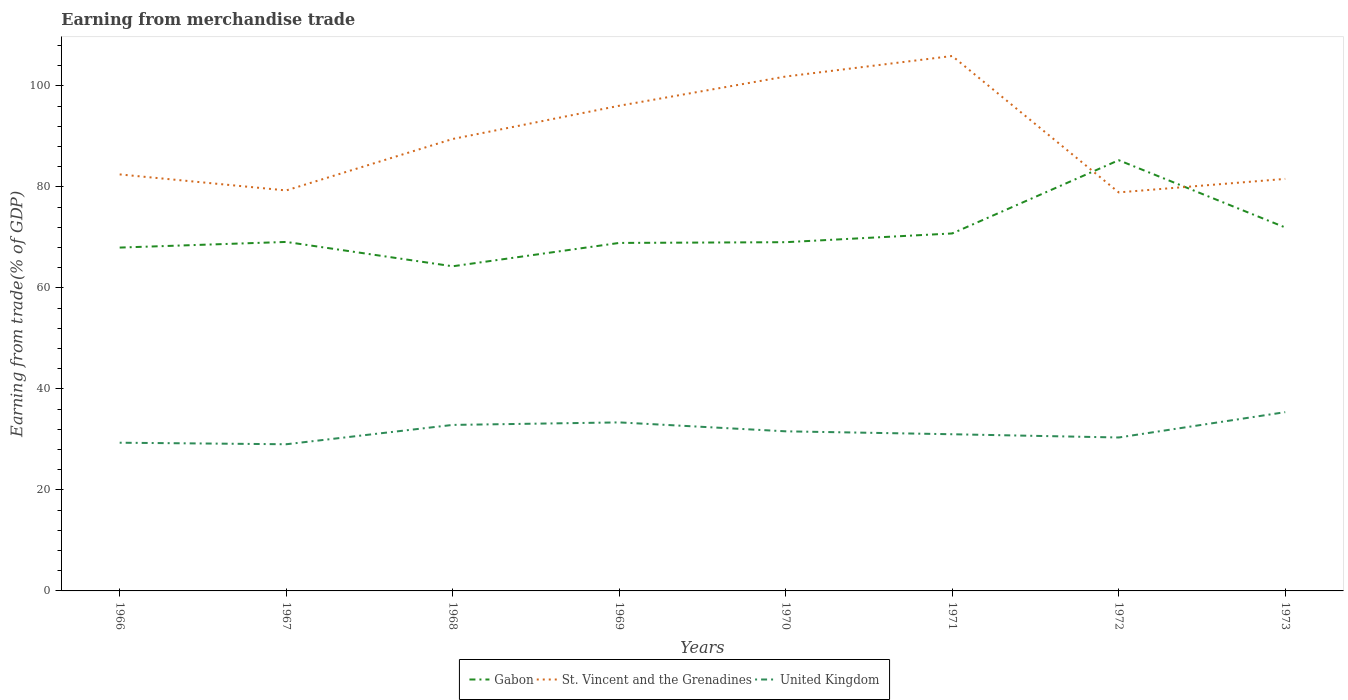How many different coloured lines are there?
Offer a terse response. 3. Is the number of lines equal to the number of legend labels?
Ensure brevity in your answer.  Yes. Across all years, what is the maximum earnings from trade in St. Vincent and the Grenadines?
Offer a terse response. 78.93. In which year was the earnings from trade in United Kingdom maximum?
Give a very brief answer. 1967. What is the total earnings from trade in United Kingdom in the graph?
Your answer should be compact. -4.33. What is the difference between the highest and the second highest earnings from trade in St. Vincent and the Grenadines?
Offer a terse response. 27.01. How many lines are there?
Provide a short and direct response. 3. Are the values on the major ticks of Y-axis written in scientific E-notation?
Your answer should be compact. No. Does the graph contain any zero values?
Ensure brevity in your answer.  No. Does the graph contain grids?
Provide a short and direct response. No. Where does the legend appear in the graph?
Provide a short and direct response. Bottom center. How are the legend labels stacked?
Provide a short and direct response. Horizontal. What is the title of the graph?
Provide a succinct answer. Earning from merchandise trade. Does "Pacific island small states" appear as one of the legend labels in the graph?
Ensure brevity in your answer.  No. What is the label or title of the Y-axis?
Give a very brief answer. Earning from trade(% of GDP). What is the Earning from trade(% of GDP) in Gabon in 1966?
Ensure brevity in your answer.  68. What is the Earning from trade(% of GDP) in St. Vincent and the Grenadines in 1966?
Your answer should be very brief. 82.49. What is the Earning from trade(% of GDP) of United Kingdom in 1966?
Offer a terse response. 29.35. What is the Earning from trade(% of GDP) of Gabon in 1967?
Provide a short and direct response. 69.11. What is the Earning from trade(% of GDP) in St. Vincent and the Grenadines in 1967?
Keep it short and to the point. 79.31. What is the Earning from trade(% of GDP) of United Kingdom in 1967?
Keep it short and to the point. 29.04. What is the Earning from trade(% of GDP) of Gabon in 1968?
Your response must be concise. 64.29. What is the Earning from trade(% of GDP) of St. Vincent and the Grenadines in 1968?
Keep it short and to the point. 89.5. What is the Earning from trade(% of GDP) of United Kingdom in 1968?
Give a very brief answer. 32.87. What is the Earning from trade(% of GDP) of Gabon in 1969?
Offer a terse response. 68.92. What is the Earning from trade(% of GDP) of St. Vincent and the Grenadines in 1969?
Provide a short and direct response. 96.08. What is the Earning from trade(% of GDP) in United Kingdom in 1969?
Give a very brief answer. 33.37. What is the Earning from trade(% of GDP) of Gabon in 1970?
Make the answer very short. 69.06. What is the Earning from trade(% of GDP) in St. Vincent and the Grenadines in 1970?
Offer a terse response. 101.87. What is the Earning from trade(% of GDP) of United Kingdom in 1970?
Offer a terse response. 31.61. What is the Earning from trade(% of GDP) of Gabon in 1971?
Provide a short and direct response. 70.79. What is the Earning from trade(% of GDP) of St. Vincent and the Grenadines in 1971?
Give a very brief answer. 105.94. What is the Earning from trade(% of GDP) of United Kingdom in 1971?
Provide a short and direct response. 31.03. What is the Earning from trade(% of GDP) of Gabon in 1972?
Offer a very short reply. 85.3. What is the Earning from trade(% of GDP) in St. Vincent and the Grenadines in 1972?
Offer a terse response. 78.93. What is the Earning from trade(% of GDP) of United Kingdom in 1972?
Give a very brief answer. 30.39. What is the Earning from trade(% of GDP) of Gabon in 1973?
Keep it short and to the point. 71.98. What is the Earning from trade(% of GDP) of St. Vincent and the Grenadines in 1973?
Your answer should be very brief. 81.6. What is the Earning from trade(% of GDP) in United Kingdom in 1973?
Make the answer very short. 35.4. Across all years, what is the maximum Earning from trade(% of GDP) of Gabon?
Make the answer very short. 85.3. Across all years, what is the maximum Earning from trade(% of GDP) in St. Vincent and the Grenadines?
Your answer should be very brief. 105.94. Across all years, what is the maximum Earning from trade(% of GDP) of United Kingdom?
Your response must be concise. 35.4. Across all years, what is the minimum Earning from trade(% of GDP) of Gabon?
Make the answer very short. 64.29. Across all years, what is the minimum Earning from trade(% of GDP) of St. Vincent and the Grenadines?
Provide a succinct answer. 78.93. Across all years, what is the minimum Earning from trade(% of GDP) in United Kingdom?
Keep it short and to the point. 29.04. What is the total Earning from trade(% of GDP) in Gabon in the graph?
Offer a terse response. 567.46. What is the total Earning from trade(% of GDP) in St. Vincent and the Grenadines in the graph?
Offer a very short reply. 715.72. What is the total Earning from trade(% of GDP) in United Kingdom in the graph?
Provide a short and direct response. 253.07. What is the difference between the Earning from trade(% of GDP) of Gabon in 1966 and that in 1967?
Your response must be concise. -1.12. What is the difference between the Earning from trade(% of GDP) of St. Vincent and the Grenadines in 1966 and that in 1967?
Give a very brief answer. 3.17. What is the difference between the Earning from trade(% of GDP) in United Kingdom in 1966 and that in 1967?
Ensure brevity in your answer.  0.31. What is the difference between the Earning from trade(% of GDP) of Gabon in 1966 and that in 1968?
Give a very brief answer. 3.7. What is the difference between the Earning from trade(% of GDP) of St. Vincent and the Grenadines in 1966 and that in 1968?
Your response must be concise. -7.02. What is the difference between the Earning from trade(% of GDP) in United Kingdom in 1966 and that in 1968?
Provide a short and direct response. -3.52. What is the difference between the Earning from trade(% of GDP) in Gabon in 1966 and that in 1969?
Make the answer very short. -0.92. What is the difference between the Earning from trade(% of GDP) of St. Vincent and the Grenadines in 1966 and that in 1969?
Offer a terse response. -13.6. What is the difference between the Earning from trade(% of GDP) of United Kingdom in 1966 and that in 1969?
Your answer should be compact. -4.02. What is the difference between the Earning from trade(% of GDP) in Gabon in 1966 and that in 1970?
Your response must be concise. -1.07. What is the difference between the Earning from trade(% of GDP) in St. Vincent and the Grenadines in 1966 and that in 1970?
Make the answer very short. -19.39. What is the difference between the Earning from trade(% of GDP) of United Kingdom in 1966 and that in 1970?
Your answer should be very brief. -2.26. What is the difference between the Earning from trade(% of GDP) in Gabon in 1966 and that in 1971?
Offer a very short reply. -2.8. What is the difference between the Earning from trade(% of GDP) of St. Vincent and the Grenadines in 1966 and that in 1971?
Make the answer very short. -23.45. What is the difference between the Earning from trade(% of GDP) in United Kingdom in 1966 and that in 1971?
Make the answer very short. -1.68. What is the difference between the Earning from trade(% of GDP) in Gabon in 1966 and that in 1972?
Provide a succinct answer. -17.31. What is the difference between the Earning from trade(% of GDP) of St. Vincent and the Grenadines in 1966 and that in 1972?
Offer a very short reply. 3.56. What is the difference between the Earning from trade(% of GDP) in United Kingdom in 1966 and that in 1972?
Your answer should be compact. -1.03. What is the difference between the Earning from trade(% of GDP) in Gabon in 1966 and that in 1973?
Offer a terse response. -3.98. What is the difference between the Earning from trade(% of GDP) of St. Vincent and the Grenadines in 1966 and that in 1973?
Your answer should be very brief. 0.89. What is the difference between the Earning from trade(% of GDP) in United Kingdom in 1966 and that in 1973?
Give a very brief answer. -6.05. What is the difference between the Earning from trade(% of GDP) in Gabon in 1967 and that in 1968?
Give a very brief answer. 4.82. What is the difference between the Earning from trade(% of GDP) of St. Vincent and the Grenadines in 1967 and that in 1968?
Offer a very short reply. -10.19. What is the difference between the Earning from trade(% of GDP) in United Kingdom in 1967 and that in 1968?
Your response must be concise. -3.83. What is the difference between the Earning from trade(% of GDP) of Gabon in 1967 and that in 1969?
Provide a succinct answer. 0.2. What is the difference between the Earning from trade(% of GDP) in St. Vincent and the Grenadines in 1967 and that in 1969?
Offer a terse response. -16.77. What is the difference between the Earning from trade(% of GDP) in United Kingdom in 1967 and that in 1969?
Make the answer very short. -4.33. What is the difference between the Earning from trade(% of GDP) of Gabon in 1967 and that in 1970?
Offer a very short reply. 0.05. What is the difference between the Earning from trade(% of GDP) of St. Vincent and the Grenadines in 1967 and that in 1970?
Give a very brief answer. -22.56. What is the difference between the Earning from trade(% of GDP) of United Kingdom in 1967 and that in 1970?
Provide a short and direct response. -2.56. What is the difference between the Earning from trade(% of GDP) of Gabon in 1967 and that in 1971?
Your answer should be compact. -1.68. What is the difference between the Earning from trade(% of GDP) of St. Vincent and the Grenadines in 1967 and that in 1971?
Keep it short and to the point. -26.63. What is the difference between the Earning from trade(% of GDP) of United Kingdom in 1967 and that in 1971?
Keep it short and to the point. -1.98. What is the difference between the Earning from trade(% of GDP) in Gabon in 1967 and that in 1972?
Your answer should be compact. -16.19. What is the difference between the Earning from trade(% of GDP) of St. Vincent and the Grenadines in 1967 and that in 1972?
Your answer should be compact. 0.39. What is the difference between the Earning from trade(% of GDP) in United Kingdom in 1967 and that in 1972?
Offer a terse response. -1.34. What is the difference between the Earning from trade(% of GDP) in Gabon in 1967 and that in 1973?
Your answer should be compact. -2.86. What is the difference between the Earning from trade(% of GDP) in St. Vincent and the Grenadines in 1967 and that in 1973?
Your answer should be very brief. -2.29. What is the difference between the Earning from trade(% of GDP) in United Kingdom in 1967 and that in 1973?
Your response must be concise. -6.36. What is the difference between the Earning from trade(% of GDP) in Gabon in 1968 and that in 1969?
Keep it short and to the point. -4.62. What is the difference between the Earning from trade(% of GDP) of St. Vincent and the Grenadines in 1968 and that in 1969?
Ensure brevity in your answer.  -6.58. What is the difference between the Earning from trade(% of GDP) of United Kingdom in 1968 and that in 1969?
Offer a terse response. -0.5. What is the difference between the Earning from trade(% of GDP) in Gabon in 1968 and that in 1970?
Ensure brevity in your answer.  -4.77. What is the difference between the Earning from trade(% of GDP) of St. Vincent and the Grenadines in 1968 and that in 1970?
Your answer should be compact. -12.37. What is the difference between the Earning from trade(% of GDP) of United Kingdom in 1968 and that in 1970?
Your response must be concise. 1.27. What is the difference between the Earning from trade(% of GDP) of Gabon in 1968 and that in 1971?
Your answer should be very brief. -6.5. What is the difference between the Earning from trade(% of GDP) of St. Vincent and the Grenadines in 1968 and that in 1971?
Make the answer very short. -16.43. What is the difference between the Earning from trade(% of GDP) in United Kingdom in 1968 and that in 1971?
Make the answer very short. 1.85. What is the difference between the Earning from trade(% of GDP) in Gabon in 1968 and that in 1972?
Offer a terse response. -21.01. What is the difference between the Earning from trade(% of GDP) in St. Vincent and the Grenadines in 1968 and that in 1972?
Make the answer very short. 10.58. What is the difference between the Earning from trade(% of GDP) in United Kingdom in 1968 and that in 1972?
Provide a short and direct response. 2.49. What is the difference between the Earning from trade(% of GDP) in Gabon in 1968 and that in 1973?
Provide a short and direct response. -7.68. What is the difference between the Earning from trade(% of GDP) of St. Vincent and the Grenadines in 1968 and that in 1973?
Make the answer very short. 7.91. What is the difference between the Earning from trade(% of GDP) of United Kingdom in 1968 and that in 1973?
Your answer should be compact. -2.53. What is the difference between the Earning from trade(% of GDP) in Gabon in 1969 and that in 1970?
Ensure brevity in your answer.  -0.15. What is the difference between the Earning from trade(% of GDP) in St. Vincent and the Grenadines in 1969 and that in 1970?
Keep it short and to the point. -5.79. What is the difference between the Earning from trade(% of GDP) of United Kingdom in 1969 and that in 1970?
Ensure brevity in your answer.  1.77. What is the difference between the Earning from trade(% of GDP) of Gabon in 1969 and that in 1971?
Make the answer very short. -1.88. What is the difference between the Earning from trade(% of GDP) of St. Vincent and the Grenadines in 1969 and that in 1971?
Offer a terse response. -9.85. What is the difference between the Earning from trade(% of GDP) in United Kingdom in 1969 and that in 1971?
Your response must be concise. 2.35. What is the difference between the Earning from trade(% of GDP) in Gabon in 1969 and that in 1972?
Provide a short and direct response. -16.38. What is the difference between the Earning from trade(% of GDP) in St. Vincent and the Grenadines in 1969 and that in 1972?
Your response must be concise. 17.16. What is the difference between the Earning from trade(% of GDP) of United Kingdom in 1969 and that in 1972?
Provide a short and direct response. 2.99. What is the difference between the Earning from trade(% of GDP) of Gabon in 1969 and that in 1973?
Provide a succinct answer. -3.06. What is the difference between the Earning from trade(% of GDP) of St. Vincent and the Grenadines in 1969 and that in 1973?
Provide a short and direct response. 14.49. What is the difference between the Earning from trade(% of GDP) of United Kingdom in 1969 and that in 1973?
Provide a short and direct response. -2.03. What is the difference between the Earning from trade(% of GDP) in Gabon in 1970 and that in 1971?
Give a very brief answer. -1.73. What is the difference between the Earning from trade(% of GDP) of St. Vincent and the Grenadines in 1970 and that in 1971?
Offer a very short reply. -4.07. What is the difference between the Earning from trade(% of GDP) in United Kingdom in 1970 and that in 1971?
Offer a terse response. 0.58. What is the difference between the Earning from trade(% of GDP) of Gabon in 1970 and that in 1972?
Your answer should be compact. -16.24. What is the difference between the Earning from trade(% of GDP) in St. Vincent and the Grenadines in 1970 and that in 1972?
Offer a very short reply. 22.95. What is the difference between the Earning from trade(% of GDP) of United Kingdom in 1970 and that in 1972?
Provide a short and direct response. 1.22. What is the difference between the Earning from trade(% of GDP) of Gabon in 1970 and that in 1973?
Provide a short and direct response. -2.91. What is the difference between the Earning from trade(% of GDP) in St. Vincent and the Grenadines in 1970 and that in 1973?
Make the answer very short. 20.27. What is the difference between the Earning from trade(% of GDP) in United Kingdom in 1970 and that in 1973?
Provide a succinct answer. -3.8. What is the difference between the Earning from trade(% of GDP) in Gabon in 1971 and that in 1972?
Offer a very short reply. -14.51. What is the difference between the Earning from trade(% of GDP) of St. Vincent and the Grenadines in 1971 and that in 1972?
Give a very brief answer. 27.01. What is the difference between the Earning from trade(% of GDP) in United Kingdom in 1971 and that in 1972?
Ensure brevity in your answer.  0.64. What is the difference between the Earning from trade(% of GDP) of Gabon in 1971 and that in 1973?
Your answer should be compact. -1.18. What is the difference between the Earning from trade(% of GDP) of St. Vincent and the Grenadines in 1971 and that in 1973?
Offer a very short reply. 24.34. What is the difference between the Earning from trade(% of GDP) in United Kingdom in 1971 and that in 1973?
Give a very brief answer. -4.38. What is the difference between the Earning from trade(% of GDP) of Gabon in 1972 and that in 1973?
Offer a very short reply. 13.32. What is the difference between the Earning from trade(% of GDP) of St. Vincent and the Grenadines in 1972 and that in 1973?
Provide a succinct answer. -2.67. What is the difference between the Earning from trade(% of GDP) in United Kingdom in 1972 and that in 1973?
Keep it short and to the point. -5.02. What is the difference between the Earning from trade(% of GDP) in Gabon in 1966 and the Earning from trade(% of GDP) in St. Vincent and the Grenadines in 1967?
Offer a terse response. -11.32. What is the difference between the Earning from trade(% of GDP) in Gabon in 1966 and the Earning from trade(% of GDP) in United Kingdom in 1967?
Offer a very short reply. 38.95. What is the difference between the Earning from trade(% of GDP) of St. Vincent and the Grenadines in 1966 and the Earning from trade(% of GDP) of United Kingdom in 1967?
Make the answer very short. 53.44. What is the difference between the Earning from trade(% of GDP) of Gabon in 1966 and the Earning from trade(% of GDP) of St. Vincent and the Grenadines in 1968?
Offer a very short reply. -21.51. What is the difference between the Earning from trade(% of GDP) in Gabon in 1966 and the Earning from trade(% of GDP) in United Kingdom in 1968?
Provide a short and direct response. 35.12. What is the difference between the Earning from trade(% of GDP) in St. Vincent and the Grenadines in 1966 and the Earning from trade(% of GDP) in United Kingdom in 1968?
Offer a very short reply. 49.61. What is the difference between the Earning from trade(% of GDP) of Gabon in 1966 and the Earning from trade(% of GDP) of St. Vincent and the Grenadines in 1969?
Make the answer very short. -28.09. What is the difference between the Earning from trade(% of GDP) in Gabon in 1966 and the Earning from trade(% of GDP) in United Kingdom in 1969?
Offer a terse response. 34.62. What is the difference between the Earning from trade(% of GDP) in St. Vincent and the Grenadines in 1966 and the Earning from trade(% of GDP) in United Kingdom in 1969?
Give a very brief answer. 49.11. What is the difference between the Earning from trade(% of GDP) of Gabon in 1966 and the Earning from trade(% of GDP) of St. Vincent and the Grenadines in 1970?
Your answer should be very brief. -33.88. What is the difference between the Earning from trade(% of GDP) of Gabon in 1966 and the Earning from trade(% of GDP) of United Kingdom in 1970?
Ensure brevity in your answer.  36.39. What is the difference between the Earning from trade(% of GDP) in St. Vincent and the Grenadines in 1966 and the Earning from trade(% of GDP) in United Kingdom in 1970?
Your response must be concise. 50.88. What is the difference between the Earning from trade(% of GDP) in Gabon in 1966 and the Earning from trade(% of GDP) in St. Vincent and the Grenadines in 1971?
Your answer should be compact. -37.94. What is the difference between the Earning from trade(% of GDP) in Gabon in 1966 and the Earning from trade(% of GDP) in United Kingdom in 1971?
Provide a short and direct response. 36.97. What is the difference between the Earning from trade(% of GDP) in St. Vincent and the Grenadines in 1966 and the Earning from trade(% of GDP) in United Kingdom in 1971?
Your answer should be very brief. 51.46. What is the difference between the Earning from trade(% of GDP) in Gabon in 1966 and the Earning from trade(% of GDP) in St. Vincent and the Grenadines in 1972?
Ensure brevity in your answer.  -10.93. What is the difference between the Earning from trade(% of GDP) in Gabon in 1966 and the Earning from trade(% of GDP) in United Kingdom in 1972?
Make the answer very short. 37.61. What is the difference between the Earning from trade(% of GDP) of St. Vincent and the Grenadines in 1966 and the Earning from trade(% of GDP) of United Kingdom in 1972?
Keep it short and to the point. 52.1. What is the difference between the Earning from trade(% of GDP) in Gabon in 1966 and the Earning from trade(% of GDP) in St. Vincent and the Grenadines in 1973?
Provide a succinct answer. -13.6. What is the difference between the Earning from trade(% of GDP) of Gabon in 1966 and the Earning from trade(% of GDP) of United Kingdom in 1973?
Offer a very short reply. 32.59. What is the difference between the Earning from trade(% of GDP) in St. Vincent and the Grenadines in 1966 and the Earning from trade(% of GDP) in United Kingdom in 1973?
Keep it short and to the point. 47.08. What is the difference between the Earning from trade(% of GDP) of Gabon in 1967 and the Earning from trade(% of GDP) of St. Vincent and the Grenadines in 1968?
Your answer should be compact. -20.39. What is the difference between the Earning from trade(% of GDP) of Gabon in 1967 and the Earning from trade(% of GDP) of United Kingdom in 1968?
Provide a short and direct response. 36.24. What is the difference between the Earning from trade(% of GDP) of St. Vincent and the Grenadines in 1967 and the Earning from trade(% of GDP) of United Kingdom in 1968?
Keep it short and to the point. 46.44. What is the difference between the Earning from trade(% of GDP) in Gabon in 1967 and the Earning from trade(% of GDP) in St. Vincent and the Grenadines in 1969?
Make the answer very short. -26.97. What is the difference between the Earning from trade(% of GDP) of Gabon in 1967 and the Earning from trade(% of GDP) of United Kingdom in 1969?
Provide a short and direct response. 35.74. What is the difference between the Earning from trade(% of GDP) of St. Vincent and the Grenadines in 1967 and the Earning from trade(% of GDP) of United Kingdom in 1969?
Ensure brevity in your answer.  45.94. What is the difference between the Earning from trade(% of GDP) of Gabon in 1967 and the Earning from trade(% of GDP) of St. Vincent and the Grenadines in 1970?
Ensure brevity in your answer.  -32.76. What is the difference between the Earning from trade(% of GDP) in Gabon in 1967 and the Earning from trade(% of GDP) in United Kingdom in 1970?
Offer a terse response. 37.51. What is the difference between the Earning from trade(% of GDP) in St. Vincent and the Grenadines in 1967 and the Earning from trade(% of GDP) in United Kingdom in 1970?
Provide a short and direct response. 47.7. What is the difference between the Earning from trade(% of GDP) of Gabon in 1967 and the Earning from trade(% of GDP) of St. Vincent and the Grenadines in 1971?
Keep it short and to the point. -36.82. What is the difference between the Earning from trade(% of GDP) in Gabon in 1967 and the Earning from trade(% of GDP) in United Kingdom in 1971?
Offer a terse response. 38.09. What is the difference between the Earning from trade(% of GDP) of St. Vincent and the Grenadines in 1967 and the Earning from trade(% of GDP) of United Kingdom in 1971?
Make the answer very short. 48.28. What is the difference between the Earning from trade(% of GDP) of Gabon in 1967 and the Earning from trade(% of GDP) of St. Vincent and the Grenadines in 1972?
Ensure brevity in your answer.  -9.81. What is the difference between the Earning from trade(% of GDP) of Gabon in 1967 and the Earning from trade(% of GDP) of United Kingdom in 1972?
Ensure brevity in your answer.  38.73. What is the difference between the Earning from trade(% of GDP) of St. Vincent and the Grenadines in 1967 and the Earning from trade(% of GDP) of United Kingdom in 1972?
Keep it short and to the point. 48.93. What is the difference between the Earning from trade(% of GDP) in Gabon in 1967 and the Earning from trade(% of GDP) in St. Vincent and the Grenadines in 1973?
Make the answer very short. -12.48. What is the difference between the Earning from trade(% of GDP) in Gabon in 1967 and the Earning from trade(% of GDP) in United Kingdom in 1973?
Your response must be concise. 33.71. What is the difference between the Earning from trade(% of GDP) of St. Vincent and the Grenadines in 1967 and the Earning from trade(% of GDP) of United Kingdom in 1973?
Your answer should be compact. 43.91. What is the difference between the Earning from trade(% of GDP) of Gabon in 1968 and the Earning from trade(% of GDP) of St. Vincent and the Grenadines in 1969?
Provide a succinct answer. -31.79. What is the difference between the Earning from trade(% of GDP) in Gabon in 1968 and the Earning from trade(% of GDP) in United Kingdom in 1969?
Give a very brief answer. 30.92. What is the difference between the Earning from trade(% of GDP) in St. Vincent and the Grenadines in 1968 and the Earning from trade(% of GDP) in United Kingdom in 1969?
Your answer should be very brief. 56.13. What is the difference between the Earning from trade(% of GDP) of Gabon in 1968 and the Earning from trade(% of GDP) of St. Vincent and the Grenadines in 1970?
Provide a succinct answer. -37.58. What is the difference between the Earning from trade(% of GDP) in Gabon in 1968 and the Earning from trade(% of GDP) in United Kingdom in 1970?
Make the answer very short. 32.69. What is the difference between the Earning from trade(% of GDP) of St. Vincent and the Grenadines in 1968 and the Earning from trade(% of GDP) of United Kingdom in 1970?
Your answer should be very brief. 57.9. What is the difference between the Earning from trade(% of GDP) in Gabon in 1968 and the Earning from trade(% of GDP) in St. Vincent and the Grenadines in 1971?
Offer a terse response. -41.65. What is the difference between the Earning from trade(% of GDP) of Gabon in 1968 and the Earning from trade(% of GDP) of United Kingdom in 1971?
Ensure brevity in your answer.  33.27. What is the difference between the Earning from trade(% of GDP) of St. Vincent and the Grenadines in 1968 and the Earning from trade(% of GDP) of United Kingdom in 1971?
Your answer should be very brief. 58.48. What is the difference between the Earning from trade(% of GDP) in Gabon in 1968 and the Earning from trade(% of GDP) in St. Vincent and the Grenadines in 1972?
Offer a terse response. -14.63. What is the difference between the Earning from trade(% of GDP) in Gabon in 1968 and the Earning from trade(% of GDP) in United Kingdom in 1972?
Your response must be concise. 33.91. What is the difference between the Earning from trade(% of GDP) in St. Vincent and the Grenadines in 1968 and the Earning from trade(% of GDP) in United Kingdom in 1972?
Offer a terse response. 59.12. What is the difference between the Earning from trade(% of GDP) of Gabon in 1968 and the Earning from trade(% of GDP) of St. Vincent and the Grenadines in 1973?
Your answer should be very brief. -17.3. What is the difference between the Earning from trade(% of GDP) in Gabon in 1968 and the Earning from trade(% of GDP) in United Kingdom in 1973?
Your answer should be compact. 28.89. What is the difference between the Earning from trade(% of GDP) in St. Vincent and the Grenadines in 1968 and the Earning from trade(% of GDP) in United Kingdom in 1973?
Keep it short and to the point. 54.1. What is the difference between the Earning from trade(% of GDP) of Gabon in 1969 and the Earning from trade(% of GDP) of St. Vincent and the Grenadines in 1970?
Your answer should be compact. -32.96. What is the difference between the Earning from trade(% of GDP) in Gabon in 1969 and the Earning from trade(% of GDP) in United Kingdom in 1970?
Ensure brevity in your answer.  37.31. What is the difference between the Earning from trade(% of GDP) in St. Vincent and the Grenadines in 1969 and the Earning from trade(% of GDP) in United Kingdom in 1970?
Keep it short and to the point. 64.48. What is the difference between the Earning from trade(% of GDP) in Gabon in 1969 and the Earning from trade(% of GDP) in St. Vincent and the Grenadines in 1971?
Your response must be concise. -37.02. What is the difference between the Earning from trade(% of GDP) of Gabon in 1969 and the Earning from trade(% of GDP) of United Kingdom in 1971?
Keep it short and to the point. 37.89. What is the difference between the Earning from trade(% of GDP) of St. Vincent and the Grenadines in 1969 and the Earning from trade(% of GDP) of United Kingdom in 1971?
Make the answer very short. 65.06. What is the difference between the Earning from trade(% of GDP) in Gabon in 1969 and the Earning from trade(% of GDP) in St. Vincent and the Grenadines in 1972?
Your answer should be compact. -10.01. What is the difference between the Earning from trade(% of GDP) of Gabon in 1969 and the Earning from trade(% of GDP) of United Kingdom in 1972?
Your answer should be very brief. 38.53. What is the difference between the Earning from trade(% of GDP) of St. Vincent and the Grenadines in 1969 and the Earning from trade(% of GDP) of United Kingdom in 1972?
Offer a terse response. 65.7. What is the difference between the Earning from trade(% of GDP) of Gabon in 1969 and the Earning from trade(% of GDP) of St. Vincent and the Grenadines in 1973?
Provide a short and direct response. -12.68. What is the difference between the Earning from trade(% of GDP) in Gabon in 1969 and the Earning from trade(% of GDP) in United Kingdom in 1973?
Provide a short and direct response. 33.51. What is the difference between the Earning from trade(% of GDP) of St. Vincent and the Grenadines in 1969 and the Earning from trade(% of GDP) of United Kingdom in 1973?
Offer a very short reply. 60.68. What is the difference between the Earning from trade(% of GDP) of Gabon in 1970 and the Earning from trade(% of GDP) of St. Vincent and the Grenadines in 1971?
Your answer should be very brief. -36.87. What is the difference between the Earning from trade(% of GDP) in Gabon in 1970 and the Earning from trade(% of GDP) in United Kingdom in 1971?
Keep it short and to the point. 38.04. What is the difference between the Earning from trade(% of GDP) of St. Vincent and the Grenadines in 1970 and the Earning from trade(% of GDP) of United Kingdom in 1971?
Your response must be concise. 70.84. What is the difference between the Earning from trade(% of GDP) of Gabon in 1970 and the Earning from trade(% of GDP) of St. Vincent and the Grenadines in 1972?
Ensure brevity in your answer.  -9.86. What is the difference between the Earning from trade(% of GDP) of Gabon in 1970 and the Earning from trade(% of GDP) of United Kingdom in 1972?
Provide a short and direct response. 38.68. What is the difference between the Earning from trade(% of GDP) in St. Vincent and the Grenadines in 1970 and the Earning from trade(% of GDP) in United Kingdom in 1972?
Keep it short and to the point. 71.49. What is the difference between the Earning from trade(% of GDP) in Gabon in 1970 and the Earning from trade(% of GDP) in St. Vincent and the Grenadines in 1973?
Give a very brief answer. -12.53. What is the difference between the Earning from trade(% of GDP) in Gabon in 1970 and the Earning from trade(% of GDP) in United Kingdom in 1973?
Ensure brevity in your answer.  33.66. What is the difference between the Earning from trade(% of GDP) of St. Vincent and the Grenadines in 1970 and the Earning from trade(% of GDP) of United Kingdom in 1973?
Your answer should be very brief. 66.47. What is the difference between the Earning from trade(% of GDP) of Gabon in 1971 and the Earning from trade(% of GDP) of St. Vincent and the Grenadines in 1972?
Provide a short and direct response. -8.13. What is the difference between the Earning from trade(% of GDP) of Gabon in 1971 and the Earning from trade(% of GDP) of United Kingdom in 1972?
Give a very brief answer. 40.41. What is the difference between the Earning from trade(% of GDP) in St. Vincent and the Grenadines in 1971 and the Earning from trade(% of GDP) in United Kingdom in 1972?
Offer a terse response. 75.55. What is the difference between the Earning from trade(% of GDP) of Gabon in 1971 and the Earning from trade(% of GDP) of St. Vincent and the Grenadines in 1973?
Your answer should be very brief. -10.8. What is the difference between the Earning from trade(% of GDP) of Gabon in 1971 and the Earning from trade(% of GDP) of United Kingdom in 1973?
Offer a terse response. 35.39. What is the difference between the Earning from trade(% of GDP) in St. Vincent and the Grenadines in 1971 and the Earning from trade(% of GDP) in United Kingdom in 1973?
Your answer should be very brief. 70.53. What is the difference between the Earning from trade(% of GDP) of Gabon in 1972 and the Earning from trade(% of GDP) of St. Vincent and the Grenadines in 1973?
Your response must be concise. 3.7. What is the difference between the Earning from trade(% of GDP) in Gabon in 1972 and the Earning from trade(% of GDP) in United Kingdom in 1973?
Your answer should be compact. 49.9. What is the difference between the Earning from trade(% of GDP) in St. Vincent and the Grenadines in 1972 and the Earning from trade(% of GDP) in United Kingdom in 1973?
Offer a terse response. 43.52. What is the average Earning from trade(% of GDP) in Gabon per year?
Provide a short and direct response. 70.93. What is the average Earning from trade(% of GDP) in St. Vincent and the Grenadines per year?
Your response must be concise. 89.47. What is the average Earning from trade(% of GDP) in United Kingdom per year?
Make the answer very short. 31.63. In the year 1966, what is the difference between the Earning from trade(% of GDP) of Gabon and Earning from trade(% of GDP) of St. Vincent and the Grenadines?
Your answer should be compact. -14.49. In the year 1966, what is the difference between the Earning from trade(% of GDP) of Gabon and Earning from trade(% of GDP) of United Kingdom?
Offer a terse response. 38.64. In the year 1966, what is the difference between the Earning from trade(% of GDP) of St. Vincent and the Grenadines and Earning from trade(% of GDP) of United Kingdom?
Give a very brief answer. 53.13. In the year 1967, what is the difference between the Earning from trade(% of GDP) of Gabon and Earning from trade(% of GDP) of St. Vincent and the Grenadines?
Offer a very short reply. -10.2. In the year 1967, what is the difference between the Earning from trade(% of GDP) of Gabon and Earning from trade(% of GDP) of United Kingdom?
Your answer should be very brief. 40.07. In the year 1967, what is the difference between the Earning from trade(% of GDP) of St. Vincent and the Grenadines and Earning from trade(% of GDP) of United Kingdom?
Your answer should be very brief. 50.27. In the year 1968, what is the difference between the Earning from trade(% of GDP) of Gabon and Earning from trade(% of GDP) of St. Vincent and the Grenadines?
Your answer should be compact. -25.21. In the year 1968, what is the difference between the Earning from trade(% of GDP) of Gabon and Earning from trade(% of GDP) of United Kingdom?
Provide a succinct answer. 31.42. In the year 1968, what is the difference between the Earning from trade(% of GDP) in St. Vincent and the Grenadines and Earning from trade(% of GDP) in United Kingdom?
Offer a very short reply. 56.63. In the year 1969, what is the difference between the Earning from trade(% of GDP) in Gabon and Earning from trade(% of GDP) in St. Vincent and the Grenadines?
Your answer should be very brief. -27.17. In the year 1969, what is the difference between the Earning from trade(% of GDP) in Gabon and Earning from trade(% of GDP) in United Kingdom?
Offer a terse response. 35.54. In the year 1969, what is the difference between the Earning from trade(% of GDP) in St. Vincent and the Grenadines and Earning from trade(% of GDP) in United Kingdom?
Your answer should be compact. 62.71. In the year 1970, what is the difference between the Earning from trade(% of GDP) in Gabon and Earning from trade(% of GDP) in St. Vincent and the Grenadines?
Provide a succinct answer. -32.81. In the year 1970, what is the difference between the Earning from trade(% of GDP) of Gabon and Earning from trade(% of GDP) of United Kingdom?
Ensure brevity in your answer.  37.46. In the year 1970, what is the difference between the Earning from trade(% of GDP) in St. Vincent and the Grenadines and Earning from trade(% of GDP) in United Kingdom?
Your response must be concise. 70.27. In the year 1971, what is the difference between the Earning from trade(% of GDP) of Gabon and Earning from trade(% of GDP) of St. Vincent and the Grenadines?
Offer a terse response. -35.14. In the year 1971, what is the difference between the Earning from trade(% of GDP) in Gabon and Earning from trade(% of GDP) in United Kingdom?
Ensure brevity in your answer.  39.77. In the year 1971, what is the difference between the Earning from trade(% of GDP) of St. Vincent and the Grenadines and Earning from trade(% of GDP) of United Kingdom?
Your answer should be compact. 74.91. In the year 1972, what is the difference between the Earning from trade(% of GDP) in Gabon and Earning from trade(% of GDP) in St. Vincent and the Grenadines?
Your response must be concise. 6.38. In the year 1972, what is the difference between the Earning from trade(% of GDP) in Gabon and Earning from trade(% of GDP) in United Kingdom?
Give a very brief answer. 54.92. In the year 1972, what is the difference between the Earning from trade(% of GDP) in St. Vincent and the Grenadines and Earning from trade(% of GDP) in United Kingdom?
Provide a succinct answer. 48.54. In the year 1973, what is the difference between the Earning from trade(% of GDP) of Gabon and Earning from trade(% of GDP) of St. Vincent and the Grenadines?
Provide a short and direct response. -9.62. In the year 1973, what is the difference between the Earning from trade(% of GDP) in Gabon and Earning from trade(% of GDP) in United Kingdom?
Provide a succinct answer. 36.57. In the year 1973, what is the difference between the Earning from trade(% of GDP) of St. Vincent and the Grenadines and Earning from trade(% of GDP) of United Kingdom?
Your answer should be compact. 46.19. What is the ratio of the Earning from trade(% of GDP) of Gabon in 1966 to that in 1967?
Offer a terse response. 0.98. What is the ratio of the Earning from trade(% of GDP) in United Kingdom in 1966 to that in 1967?
Give a very brief answer. 1.01. What is the ratio of the Earning from trade(% of GDP) in Gabon in 1966 to that in 1968?
Provide a short and direct response. 1.06. What is the ratio of the Earning from trade(% of GDP) in St. Vincent and the Grenadines in 1966 to that in 1968?
Make the answer very short. 0.92. What is the ratio of the Earning from trade(% of GDP) in United Kingdom in 1966 to that in 1968?
Offer a very short reply. 0.89. What is the ratio of the Earning from trade(% of GDP) in Gabon in 1966 to that in 1969?
Provide a succinct answer. 0.99. What is the ratio of the Earning from trade(% of GDP) of St. Vincent and the Grenadines in 1966 to that in 1969?
Provide a succinct answer. 0.86. What is the ratio of the Earning from trade(% of GDP) of United Kingdom in 1966 to that in 1969?
Offer a terse response. 0.88. What is the ratio of the Earning from trade(% of GDP) of Gabon in 1966 to that in 1970?
Offer a very short reply. 0.98. What is the ratio of the Earning from trade(% of GDP) in St. Vincent and the Grenadines in 1966 to that in 1970?
Provide a short and direct response. 0.81. What is the ratio of the Earning from trade(% of GDP) in United Kingdom in 1966 to that in 1970?
Provide a succinct answer. 0.93. What is the ratio of the Earning from trade(% of GDP) of Gabon in 1966 to that in 1971?
Provide a succinct answer. 0.96. What is the ratio of the Earning from trade(% of GDP) in St. Vincent and the Grenadines in 1966 to that in 1971?
Offer a terse response. 0.78. What is the ratio of the Earning from trade(% of GDP) in United Kingdom in 1966 to that in 1971?
Provide a short and direct response. 0.95. What is the ratio of the Earning from trade(% of GDP) of Gabon in 1966 to that in 1972?
Your answer should be very brief. 0.8. What is the ratio of the Earning from trade(% of GDP) of St. Vincent and the Grenadines in 1966 to that in 1972?
Provide a succinct answer. 1.05. What is the ratio of the Earning from trade(% of GDP) of United Kingdom in 1966 to that in 1972?
Give a very brief answer. 0.97. What is the ratio of the Earning from trade(% of GDP) in Gabon in 1966 to that in 1973?
Make the answer very short. 0.94. What is the ratio of the Earning from trade(% of GDP) in St. Vincent and the Grenadines in 1966 to that in 1973?
Make the answer very short. 1.01. What is the ratio of the Earning from trade(% of GDP) of United Kingdom in 1966 to that in 1973?
Provide a succinct answer. 0.83. What is the ratio of the Earning from trade(% of GDP) in Gabon in 1967 to that in 1968?
Offer a very short reply. 1.07. What is the ratio of the Earning from trade(% of GDP) in St. Vincent and the Grenadines in 1967 to that in 1968?
Offer a terse response. 0.89. What is the ratio of the Earning from trade(% of GDP) in United Kingdom in 1967 to that in 1968?
Your answer should be very brief. 0.88. What is the ratio of the Earning from trade(% of GDP) of St. Vincent and the Grenadines in 1967 to that in 1969?
Your response must be concise. 0.83. What is the ratio of the Earning from trade(% of GDP) in United Kingdom in 1967 to that in 1969?
Provide a short and direct response. 0.87. What is the ratio of the Earning from trade(% of GDP) in St. Vincent and the Grenadines in 1967 to that in 1970?
Offer a very short reply. 0.78. What is the ratio of the Earning from trade(% of GDP) in United Kingdom in 1967 to that in 1970?
Ensure brevity in your answer.  0.92. What is the ratio of the Earning from trade(% of GDP) of Gabon in 1967 to that in 1971?
Your answer should be compact. 0.98. What is the ratio of the Earning from trade(% of GDP) in St. Vincent and the Grenadines in 1967 to that in 1971?
Offer a very short reply. 0.75. What is the ratio of the Earning from trade(% of GDP) of United Kingdom in 1967 to that in 1971?
Offer a terse response. 0.94. What is the ratio of the Earning from trade(% of GDP) in Gabon in 1967 to that in 1972?
Your answer should be very brief. 0.81. What is the ratio of the Earning from trade(% of GDP) in United Kingdom in 1967 to that in 1972?
Your answer should be very brief. 0.96. What is the ratio of the Earning from trade(% of GDP) in Gabon in 1967 to that in 1973?
Your response must be concise. 0.96. What is the ratio of the Earning from trade(% of GDP) in St. Vincent and the Grenadines in 1967 to that in 1973?
Keep it short and to the point. 0.97. What is the ratio of the Earning from trade(% of GDP) in United Kingdom in 1967 to that in 1973?
Make the answer very short. 0.82. What is the ratio of the Earning from trade(% of GDP) in Gabon in 1968 to that in 1969?
Offer a terse response. 0.93. What is the ratio of the Earning from trade(% of GDP) of St. Vincent and the Grenadines in 1968 to that in 1969?
Keep it short and to the point. 0.93. What is the ratio of the Earning from trade(% of GDP) in United Kingdom in 1968 to that in 1969?
Offer a terse response. 0.98. What is the ratio of the Earning from trade(% of GDP) of Gabon in 1968 to that in 1970?
Your answer should be very brief. 0.93. What is the ratio of the Earning from trade(% of GDP) of St. Vincent and the Grenadines in 1968 to that in 1970?
Your answer should be compact. 0.88. What is the ratio of the Earning from trade(% of GDP) in United Kingdom in 1968 to that in 1970?
Provide a short and direct response. 1.04. What is the ratio of the Earning from trade(% of GDP) of Gabon in 1968 to that in 1971?
Your response must be concise. 0.91. What is the ratio of the Earning from trade(% of GDP) of St. Vincent and the Grenadines in 1968 to that in 1971?
Provide a short and direct response. 0.84. What is the ratio of the Earning from trade(% of GDP) of United Kingdom in 1968 to that in 1971?
Ensure brevity in your answer.  1.06. What is the ratio of the Earning from trade(% of GDP) in Gabon in 1968 to that in 1972?
Your answer should be very brief. 0.75. What is the ratio of the Earning from trade(% of GDP) in St. Vincent and the Grenadines in 1968 to that in 1972?
Ensure brevity in your answer.  1.13. What is the ratio of the Earning from trade(% of GDP) in United Kingdom in 1968 to that in 1972?
Offer a very short reply. 1.08. What is the ratio of the Earning from trade(% of GDP) of Gabon in 1968 to that in 1973?
Your answer should be very brief. 0.89. What is the ratio of the Earning from trade(% of GDP) of St. Vincent and the Grenadines in 1968 to that in 1973?
Make the answer very short. 1.1. What is the ratio of the Earning from trade(% of GDP) in United Kingdom in 1968 to that in 1973?
Make the answer very short. 0.93. What is the ratio of the Earning from trade(% of GDP) of Gabon in 1969 to that in 1970?
Offer a very short reply. 1. What is the ratio of the Earning from trade(% of GDP) in St. Vincent and the Grenadines in 1969 to that in 1970?
Offer a very short reply. 0.94. What is the ratio of the Earning from trade(% of GDP) of United Kingdom in 1969 to that in 1970?
Your answer should be very brief. 1.06. What is the ratio of the Earning from trade(% of GDP) of Gabon in 1969 to that in 1971?
Make the answer very short. 0.97. What is the ratio of the Earning from trade(% of GDP) of St. Vincent and the Grenadines in 1969 to that in 1971?
Your answer should be compact. 0.91. What is the ratio of the Earning from trade(% of GDP) of United Kingdom in 1969 to that in 1971?
Ensure brevity in your answer.  1.08. What is the ratio of the Earning from trade(% of GDP) of Gabon in 1969 to that in 1972?
Your answer should be compact. 0.81. What is the ratio of the Earning from trade(% of GDP) in St. Vincent and the Grenadines in 1969 to that in 1972?
Offer a terse response. 1.22. What is the ratio of the Earning from trade(% of GDP) of United Kingdom in 1969 to that in 1972?
Make the answer very short. 1.1. What is the ratio of the Earning from trade(% of GDP) of Gabon in 1969 to that in 1973?
Make the answer very short. 0.96. What is the ratio of the Earning from trade(% of GDP) of St. Vincent and the Grenadines in 1969 to that in 1973?
Your answer should be compact. 1.18. What is the ratio of the Earning from trade(% of GDP) in United Kingdom in 1969 to that in 1973?
Your answer should be very brief. 0.94. What is the ratio of the Earning from trade(% of GDP) of Gabon in 1970 to that in 1971?
Your answer should be compact. 0.98. What is the ratio of the Earning from trade(% of GDP) in St. Vincent and the Grenadines in 1970 to that in 1971?
Your answer should be very brief. 0.96. What is the ratio of the Earning from trade(% of GDP) in United Kingdom in 1970 to that in 1971?
Ensure brevity in your answer.  1.02. What is the ratio of the Earning from trade(% of GDP) in Gabon in 1970 to that in 1972?
Give a very brief answer. 0.81. What is the ratio of the Earning from trade(% of GDP) in St. Vincent and the Grenadines in 1970 to that in 1972?
Make the answer very short. 1.29. What is the ratio of the Earning from trade(% of GDP) in United Kingdom in 1970 to that in 1972?
Make the answer very short. 1.04. What is the ratio of the Earning from trade(% of GDP) of Gabon in 1970 to that in 1973?
Give a very brief answer. 0.96. What is the ratio of the Earning from trade(% of GDP) in St. Vincent and the Grenadines in 1970 to that in 1973?
Offer a terse response. 1.25. What is the ratio of the Earning from trade(% of GDP) in United Kingdom in 1970 to that in 1973?
Your response must be concise. 0.89. What is the ratio of the Earning from trade(% of GDP) in Gabon in 1971 to that in 1972?
Provide a succinct answer. 0.83. What is the ratio of the Earning from trade(% of GDP) in St. Vincent and the Grenadines in 1971 to that in 1972?
Give a very brief answer. 1.34. What is the ratio of the Earning from trade(% of GDP) of United Kingdom in 1971 to that in 1972?
Keep it short and to the point. 1.02. What is the ratio of the Earning from trade(% of GDP) of Gabon in 1971 to that in 1973?
Provide a short and direct response. 0.98. What is the ratio of the Earning from trade(% of GDP) in St. Vincent and the Grenadines in 1971 to that in 1973?
Offer a very short reply. 1.3. What is the ratio of the Earning from trade(% of GDP) in United Kingdom in 1971 to that in 1973?
Offer a very short reply. 0.88. What is the ratio of the Earning from trade(% of GDP) in Gabon in 1972 to that in 1973?
Offer a very short reply. 1.19. What is the ratio of the Earning from trade(% of GDP) in St. Vincent and the Grenadines in 1972 to that in 1973?
Provide a short and direct response. 0.97. What is the ratio of the Earning from trade(% of GDP) of United Kingdom in 1972 to that in 1973?
Your response must be concise. 0.86. What is the difference between the highest and the second highest Earning from trade(% of GDP) in Gabon?
Give a very brief answer. 13.32. What is the difference between the highest and the second highest Earning from trade(% of GDP) of St. Vincent and the Grenadines?
Offer a terse response. 4.07. What is the difference between the highest and the second highest Earning from trade(% of GDP) in United Kingdom?
Ensure brevity in your answer.  2.03. What is the difference between the highest and the lowest Earning from trade(% of GDP) in Gabon?
Offer a very short reply. 21.01. What is the difference between the highest and the lowest Earning from trade(% of GDP) in St. Vincent and the Grenadines?
Offer a terse response. 27.01. What is the difference between the highest and the lowest Earning from trade(% of GDP) in United Kingdom?
Ensure brevity in your answer.  6.36. 